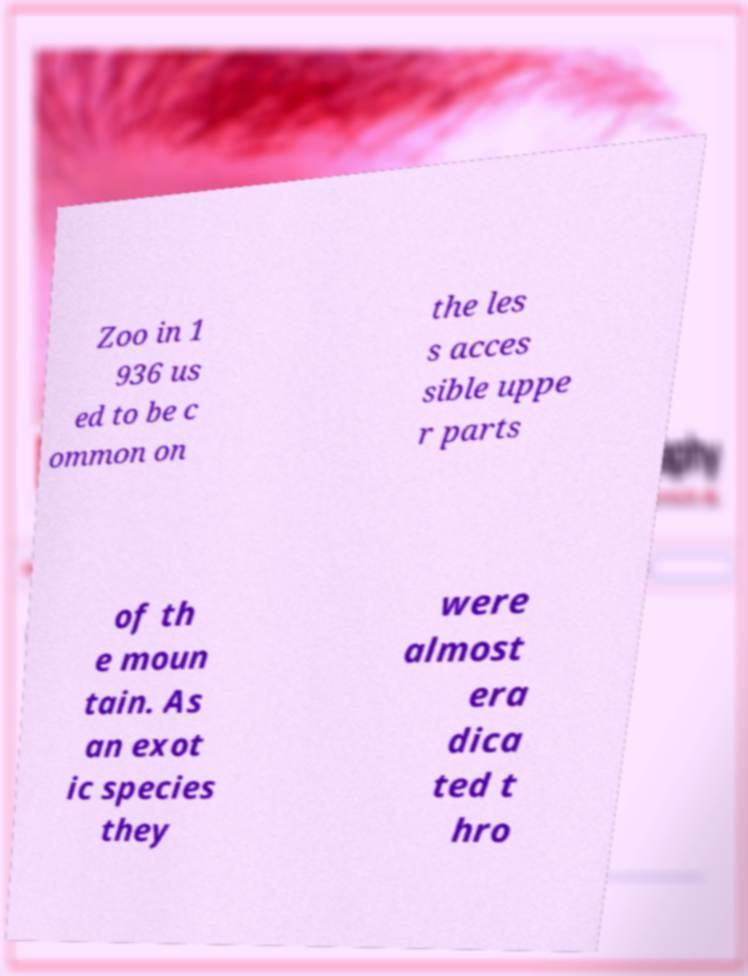I need the written content from this picture converted into text. Can you do that? Zoo in 1 936 us ed to be c ommon on the les s acces sible uppe r parts of th e moun tain. As an exot ic species they were almost era dica ted t hro 